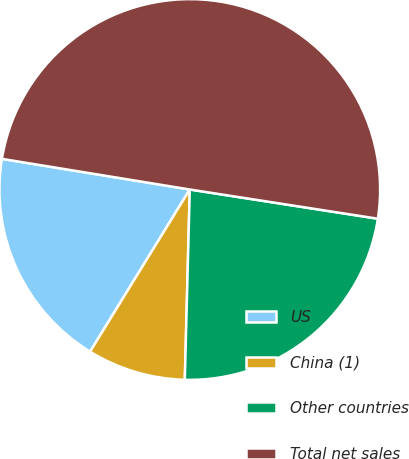<chart> <loc_0><loc_0><loc_500><loc_500><pie_chart><fcel>US<fcel>China (1)<fcel>Other countries<fcel>Total net sales<nl><fcel>18.8%<fcel>8.36%<fcel>22.96%<fcel>49.88%<nl></chart> 